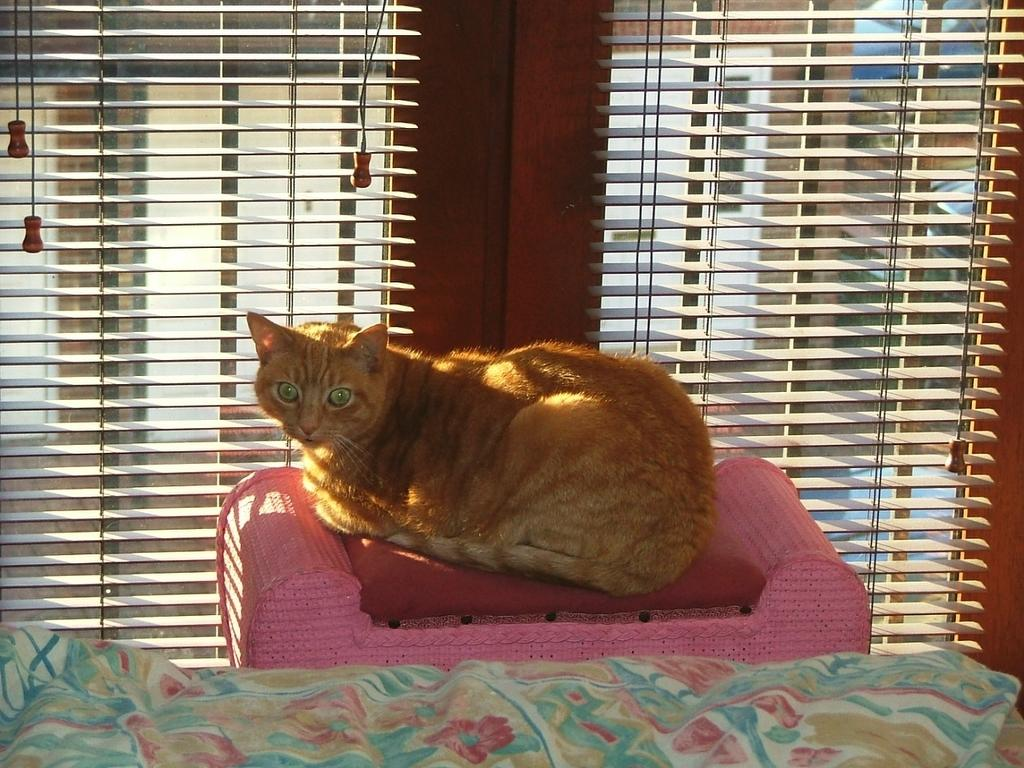What type of animal is in the image? There is a cat in the image. Where is the cat located? The cat is sitting on a couch. What is at the bottom of the image? There is a cloth at the bottom of the image. What can be seen in the background of the image? There are blinds in the background of the image. What type of cabbage is being harvested by the train in the image? There is no train or cabbage present in the image; it features a cat sitting on a couch. What time is displayed on the watch in the image? There is no watch present in the image. 